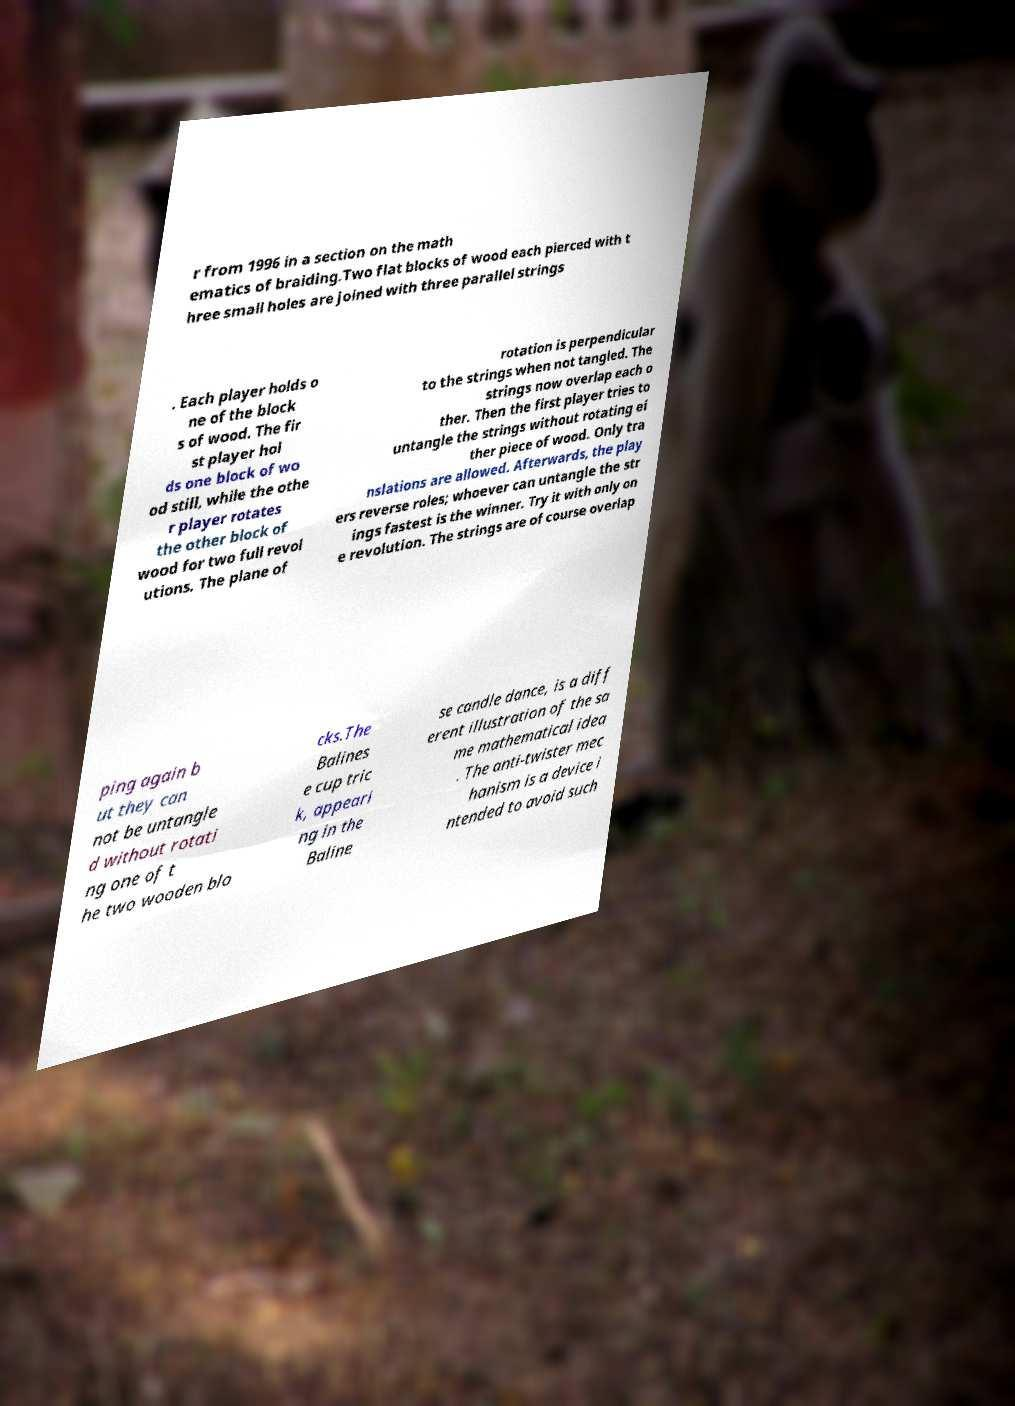Please read and relay the text visible in this image. What does it say? r from 1996 in a section on the math ematics of braiding.Two flat blocks of wood each pierced with t hree small holes are joined with three parallel strings . Each player holds o ne of the block s of wood. The fir st player hol ds one block of wo od still, while the othe r player rotates the other block of wood for two full revol utions. The plane of rotation is perpendicular to the strings when not tangled. The strings now overlap each o ther. Then the first player tries to untangle the strings without rotating ei ther piece of wood. Only tra nslations are allowed. Afterwards, the play ers reverse roles; whoever can untangle the str ings fastest is the winner. Try it with only on e revolution. The strings are of course overlap ping again b ut they can not be untangle d without rotati ng one of t he two wooden blo cks.The Balines e cup tric k, appeari ng in the Baline se candle dance, is a diff erent illustration of the sa me mathematical idea . The anti-twister mec hanism is a device i ntended to avoid such 